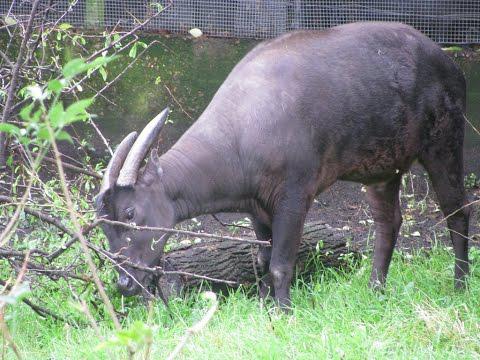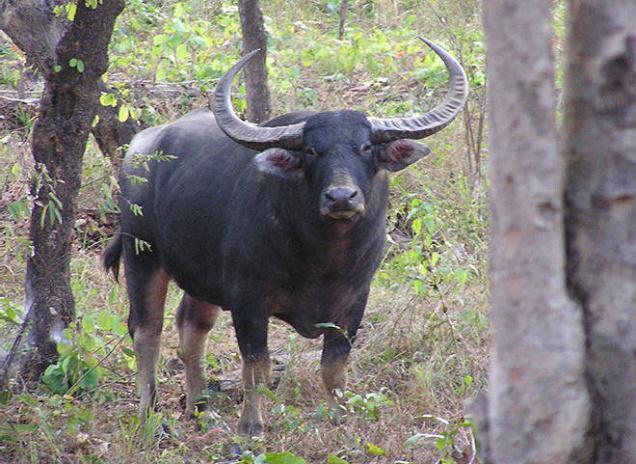The first image is the image on the left, the second image is the image on the right. Evaluate the accuracy of this statement regarding the images: "The left image contains two water buffalo's.". Is it true? Answer yes or no. No. 